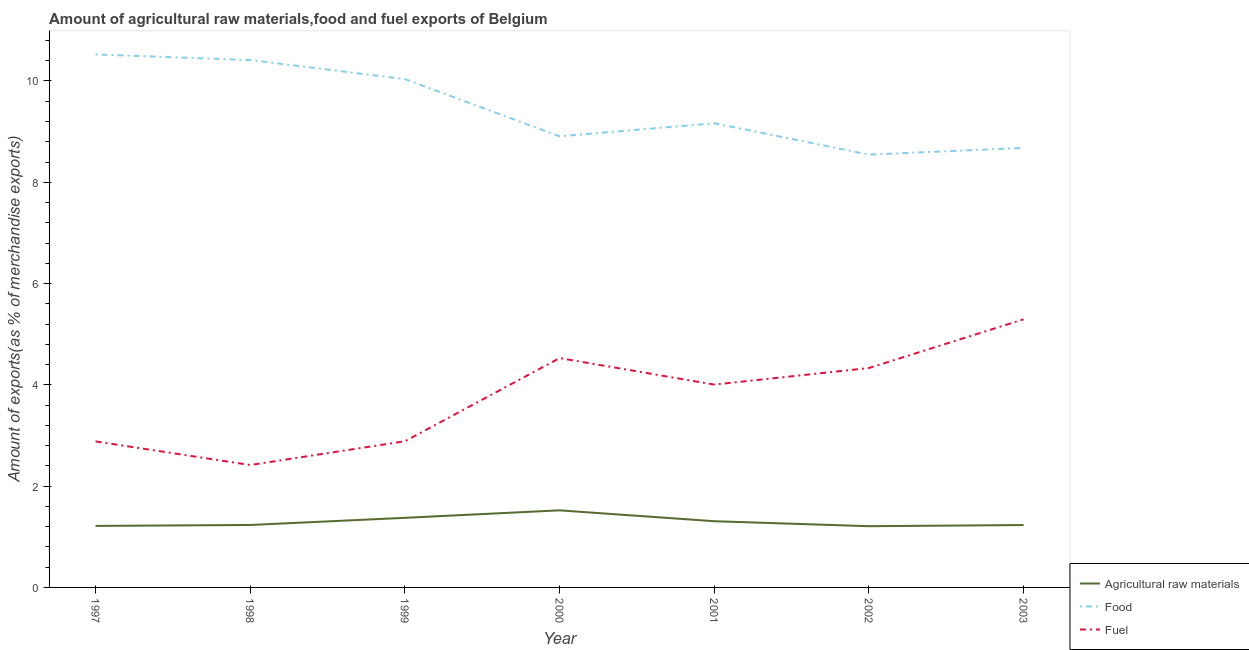How many different coloured lines are there?
Provide a succinct answer. 3. What is the percentage of food exports in 1997?
Your answer should be compact. 10.52. Across all years, what is the maximum percentage of fuel exports?
Your answer should be very brief. 5.29. Across all years, what is the minimum percentage of raw materials exports?
Offer a very short reply. 1.21. In which year was the percentage of fuel exports maximum?
Provide a succinct answer. 2003. What is the total percentage of food exports in the graph?
Make the answer very short. 66.27. What is the difference between the percentage of fuel exports in 1998 and that in 2000?
Your answer should be very brief. -2.11. What is the difference between the percentage of raw materials exports in 2000 and the percentage of food exports in 1998?
Offer a very short reply. -8.89. What is the average percentage of food exports per year?
Provide a short and direct response. 9.47. In the year 2002, what is the difference between the percentage of food exports and percentage of fuel exports?
Offer a terse response. 4.21. What is the ratio of the percentage of raw materials exports in 1997 to that in 2000?
Provide a succinct answer. 0.8. Is the difference between the percentage of raw materials exports in 1998 and 2001 greater than the difference between the percentage of fuel exports in 1998 and 2001?
Make the answer very short. Yes. What is the difference between the highest and the second highest percentage of food exports?
Offer a very short reply. 0.11. What is the difference between the highest and the lowest percentage of food exports?
Your answer should be compact. 1.98. In how many years, is the percentage of fuel exports greater than the average percentage of fuel exports taken over all years?
Your answer should be very brief. 4. Is it the case that in every year, the sum of the percentage of raw materials exports and percentage of food exports is greater than the percentage of fuel exports?
Make the answer very short. Yes. Is the percentage of food exports strictly less than the percentage of raw materials exports over the years?
Offer a terse response. No. How many lines are there?
Offer a very short reply. 3. What is the difference between two consecutive major ticks on the Y-axis?
Make the answer very short. 2. Does the graph contain any zero values?
Your answer should be very brief. No. Does the graph contain grids?
Provide a short and direct response. No. What is the title of the graph?
Offer a terse response. Amount of agricultural raw materials,food and fuel exports of Belgium. What is the label or title of the Y-axis?
Provide a short and direct response. Amount of exports(as % of merchandise exports). What is the Amount of exports(as % of merchandise exports) of Agricultural raw materials in 1997?
Offer a terse response. 1.21. What is the Amount of exports(as % of merchandise exports) in Food in 1997?
Make the answer very short. 10.52. What is the Amount of exports(as % of merchandise exports) in Fuel in 1997?
Offer a terse response. 2.88. What is the Amount of exports(as % of merchandise exports) in Agricultural raw materials in 1998?
Give a very brief answer. 1.23. What is the Amount of exports(as % of merchandise exports) of Food in 1998?
Offer a very short reply. 10.41. What is the Amount of exports(as % of merchandise exports) in Fuel in 1998?
Provide a short and direct response. 2.42. What is the Amount of exports(as % of merchandise exports) in Agricultural raw materials in 1999?
Give a very brief answer. 1.37. What is the Amount of exports(as % of merchandise exports) in Food in 1999?
Your answer should be very brief. 10.04. What is the Amount of exports(as % of merchandise exports) of Fuel in 1999?
Provide a short and direct response. 2.89. What is the Amount of exports(as % of merchandise exports) in Agricultural raw materials in 2000?
Your answer should be compact. 1.52. What is the Amount of exports(as % of merchandise exports) of Food in 2000?
Your response must be concise. 8.91. What is the Amount of exports(as % of merchandise exports) of Fuel in 2000?
Provide a short and direct response. 4.53. What is the Amount of exports(as % of merchandise exports) in Agricultural raw materials in 2001?
Ensure brevity in your answer.  1.31. What is the Amount of exports(as % of merchandise exports) in Food in 2001?
Offer a very short reply. 9.17. What is the Amount of exports(as % of merchandise exports) in Fuel in 2001?
Your answer should be compact. 4.01. What is the Amount of exports(as % of merchandise exports) of Agricultural raw materials in 2002?
Make the answer very short. 1.21. What is the Amount of exports(as % of merchandise exports) in Food in 2002?
Keep it short and to the point. 8.55. What is the Amount of exports(as % of merchandise exports) of Fuel in 2002?
Your answer should be compact. 4.33. What is the Amount of exports(as % of merchandise exports) in Agricultural raw materials in 2003?
Make the answer very short. 1.23. What is the Amount of exports(as % of merchandise exports) of Food in 2003?
Make the answer very short. 8.68. What is the Amount of exports(as % of merchandise exports) in Fuel in 2003?
Offer a very short reply. 5.29. Across all years, what is the maximum Amount of exports(as % of merchandise exports) in Agricultural raw materials?
Offer a terse response. 1.52. Across all years, what is the maximum Amount of exports(as % of merchandise exports) in Food?
Your answer should be compact. 10.52. Across all years, what is the maximum Amount of exports(as % of merchandise exports) in Fuel?
Provide a succinct answer. 5.29. Across all years, what is the minimum Amount of exports(as % of merchandise exports) of Agricultural raw materials?
Offer a very short reply. 1.21. Across all years, what is the minimum Amount of exports(as % of merchandise exports) in Food?
Keep it short and to the point. 8.55. Across all years, what is the minimum Amount of exports(as % of merchandise exports) of Fuel?
Offer a terse response. 2.42. What is the total Amount of exports(as % of merchandise exports) of Agricultural raw materials in the graph?
Provide a succinct answer. 9.09. What is the total Amount of exports(as % of merchandise exports) of Food in the graph?
Your answer should be very brief. 66.27. What is the total Amount of exports(as % of merchandise exports) in Fuel in the graph?
Offer a terse response. 26.35. What is the difference between the Amount of exports(as % of merchandise exports) in Agricultural raw materials in 1997 and that in 1998?
Your answer should be very brief. -0.02. What is the difference between the Amount of exports(as % of merchandise exports) of Food in 1997 and that in 1998?
Ensure brevity in your answer.  0.11. What is the difference between the Amount of exports(as % of merchandise exports) of Fuel in 1997 and that in 1998?
Provide a succinct answer. 0.47. What is the difference between the Amount of exports(as % of merchandise exports) of Agricultural raw materials in 1997 and that in 1999?
Keep it short and to the point. -0.16. What is the difference between the Amount of exports(as % of merchandise exports) of Food in 1997 and that in 1999?
Make the answer very short. 0.49. What is the difference between the Amount of exports(as % of merchandise exports) of Fuel in 1997 and that in 1999?
Give a very brief answer. -0. What is the difference between the Amount of exports(as % of merchandise exports) of Agricultural raw materials in 1997 and that in 2000?
Your response must be concise. -0.31. What is the difference between the Amount of exports(as % of merchandise exports) in Food in 1997 and that in 2000?
Offer a terse response. 1.62. What is the difference between the Amount of exports(as % of merchandise exports) in Fuel in 1997 and that in 2000?
Provide a short and direct response. -1.64. What is the difference between the Amount of exports(as % of merchandise exports) in Agricultural raw materials in 1997 and that in 2001?
Offer a very short reply. -0.09. What is the difference between the Amount of exports(as % of merchandise exports) in Food in 1997 and that in 2001?
Your answer should be compact. 1.36. What is the difference between the Amount of exports(as % of merchandise exports) in Fuel in 1997 and that in 2001?
Provide a short and direct response. -1.12. What is the difference between the Amount of exports(as % of merchandise exports) of Agricultural raw materials in 1997 and that in 2002?
Keep it short and to the point. 0.01. What is the difference between the Amount of exports(as % of merchandise exports) in Food in 1997 and that in 2002?
Your answer should be very brief. 1.98. What is the difference between the Amount of exports(as % of merchandise exports) of Fuel in 1997 and that in 2002?
Ensure brevity in your answer.  -1.45. What is the difference between the Amount of exports(as % of merchandise exports) of Agricultural raw materials in 1997 and that in 2003?
Offer a terse response. -0.02. What is the difference between the Amount of exports(as % of merchandise exports) in Food in 1997 and that in 2003?
Provide a short and direct response. 1.85. What is the difference between the Amount of exports(as % of merchandise exports) of Fuel in 1997 and that in 2003?
Give a very brief answer. -2.41. What is the difference between the Amount of exports(as % of merchandise exports) of Agricultural raw materials in 1998 and that in 1999?
Provide a succinct answer. -0.14. What is the difference between the Amount of exports(as % of merchandise exports) of Food in 1998 and that in 1999?
Provide a short and direct response. 0.38. What is the difference between the Amount of exports(as % of merchandise exports) in Fuel in 1998 and that in 1999?
Give a very brief answer. -0.47. What is the difference between the Amount of exports(as % of merchandise exports) of Agricultural raw materials in 1998 and that in 2000?
Your answer should be very brief. -0.29. What is the difference between the Amount of exports(as % of merchandise exports) in Food in 1998 and that in 2000?
Give a very brief answer. 1.51. What is the difference between the Amount of exports(as % of merchandise exports) of Fuel in 1998 and that in 2000?
Offer a very short reply. -2.11. What is the difference between the Amount of exports(as % of merchandise exports) of Agricultural raw materials in 1998 and that in 2001?
Give a very brief answer. -0.07. What is the difference between the Amount of exports(as % of merchandise exports) in Food in 1998 and that in 2001?
Make the answer very short. 1.25. What is the difference between the Amount of exports(as % of merchandise exports) of Fuel in 1998 and that in 2001?
Ensure brevity in your answer.  -1.59. What is the difference between the Amount of exports(as % of merchandise exports) of Agricultural raw materials in 1998 and that in 2002?
Your answer should be very brief. 0.02. What is the difference between the Amount of exports(as % of merchandise exports) of Food in 1998 and that in 2002?
Offer a very short reply. 1.87. What is the difference between the Amount of exports(as % of merchandise exports) in Fuel in 1998 and that in 2002?
Keep it short and to the point. -1.91. What is the difference between the Amount of exports(as % of merchandise exports) in Agricultural raw materials in 1998 and that in 2003?
Provide a short and direct response. 0. What is the difference between the Amount of exports(as % of merchandise exports) of Food in 1998 and that in 2003?
Ensure brevity in your answer.  1.73. What is the difference between the Amount of exports(as % of merchandise exports) of Fuel in 1998 and that in 2003?
Provide a short and direct response. -2.88. What is the difference between the Amount of exports(as % of merchandise exports) in Agricultural raw materials in 1999 and that in 2000?
Ensure brevity in your answer.  -0.15. What is the difference between the Amount of exports(as % of merchandise exports) in Food in 1999 and that in 2000?
Offer a very short reply. 1.13. What is the difference between the Amount of exports(as % of merchandise exports) in Fuel in 1999 and that in 2000?
Your answer should be very brief. -1.64. What is the difference between the Amount of exports(as % of merchandise exports) in Agricultural raw materials in 1999 and that in 2001?
Your response must be concise. 0.07. What is the difference between the Amount of exports(as % of merchandise exports) in Food in 1999 and that in 2001?
Offer a terse response. 0.87. What is the difference between the Amount of exports(as % of merchandise exports) of Fuel in 1999 and that in 2001?
Offer a terse response. -1.12. What is the difference between the Amount of exports(as % of merchandise exports) in Agricultural raw materials in 1999 and that in 2002?
Ensure brevity in your answer.  0.17. What is the difference between the Amount of exports(as % of merchandise exports) of Food in 1999 and that in 2002?
Your answer should be compact. 1.49. What is the difference between the Amount of exports(as % of merchandise exports) in Fuel in 1999 and that in 2002?
Offer a very short reply. -1.45. What is the difference between the Amount of exports(as % of merchandise exports) of Agricultural raw materials in 1999 and that in 2003?
Make the answer very short. 0.14. What is the difference between the Amount of exports(as % of merchandise exports) in Food in 1999 and that in 2003?
Provide a succinct answer. 1.36. What is the difference between the Amount of exports(as % of merchandise exports) of Fuel in 1999 and that in 2003?
Your answer should be very brief. -2.41. What is the difference between the Amount of exports(as % of merchandise exports) in Agricultural raw materials in 2000 and that in 2001?
Provide a short and direct response. 0.21. What is the difference between the Amount of exports(as % of merchandise exports) of Food in 2000 and that in 2001?
Keep it short and to the point. -0.26. What is the difference between the Amount of exports(as % of merchandise exports) in Fuel in 2000 and that in 2001?
Ensure brevity in your answer.  0.52. What is the difference between the Amount of exports(as % of merchandise exports) of Agricultural raw materials in 2000 and that in 2002?
Provide a short and direct response. 0.31. What is the difference between the Amount of exports(as % of merchandise exports) of Food in 2000 and that in 2002?
Offer a very short reply. 0.36. What is the difference between the Amount of exports(as % of merchandise exports) in Fuel in 2000 and that in 2002?
Offer a very short reply. 0.2. What is the difference between the Amount of exports(as % of merchandise exports) of Agricultural raw materials in 2000 and that in 2003?
Ensure brevity in your answer.  0.29. What is the difference between the Amount of exports(as % of merchandise exports) of Food in 2000 and that in 2003?
Your answer should be compact. 0.23. What is the difference between the Amount of exports(as % of merchandise exports) in Fuel in 2000 and that in 2003?
Your response must be concise. -0.77. What is the difference between the Amount of exports(as % of merchandise exports) of Agricultural raw materials in 2001 and that in 2002?
Give a very brief answer. 0.1. What is the difference between the Amount of exports(as % of merchandise exports) of Food in 2001 and that in 2002?
Ensure brevity in your answer.  0.62. What is the difference between the Amount of exports(as % of merchandise exports) in Fuel in 2001 and that in 2002?
Make the answer very short. -0.33. What is the difference between the Amount of exports(as % of merchandise exports) in Agricultural raw materials in 2001 and that in 2003?
Provide a short and direct response. 0.08. What is the difference between the Amount of exports(as % of merchandise exports) in Food in 2001 and that in 2003?
Keep it short and to the point. 0.49. What is the difference between the Amount of exports(as % of merchandise exports) of Fuel in 2001 and that in 2003?
Provide a succinct answer. -1.29. What is the difference between the Amount of exports(as % of merchandise exports) in Agricultural raw materials in 2002 and that in 2003?
Provide a succinct answer. -0.02. What is the difference between the Amount of exports(as % of merchandise exports) of Food in 2002 and that in 2003?
Provide a short and direct response. -0.13. What is the difference between the Amount of exports(as % of merchandise exports) of Fuel in 2002 and that in 2003?
Give a very brief answer. -0.96. What is the difference between the Amount of exports(as % of merchandise exports) in Agricultural raw materials in 1997 and the Amount of exports(as % of merchandise exports) in Food in 1998?
Your answer should be very brief. -9.2. What is the difference between the Amount of exports(as % of merchandise exports) in Agricultural raw materials in 1997 and the Amount of exports(as % of merchandise exports) in Fuel in 1998?
Make the answer very short. -1.2. What is the difference between the Amount of exports(as % of merchandise exports) of Food in 1997 and the Amount of exports(as % of merchandise exports) of Fuel in 1998?
Your answer should be compact. 8.11. What is the difference between the Amount of exports(as % of merchandise exports) of Agricultural raw materials in 1997 and the Amount of exports(as % of merchandise exports) of Food in 1999?
Make the answer very short. -8.82. What is the difference between the Amount of exports(as % of merchandise exports) in Agricultural raw materials in 1997 and the Amount of exports(as % of merchandise exports) in Fuel in 1999?
Give a very brief answer. -1.67. What is the difference between the Amount of exports(as % of merchandise exports) of Food in 1997 and the Amount of exports(as % of merchandise exports) of Fuel in 1999?
Make the answer very short. 7.64. What is the difference between the Amount of exports(as % of merchandise exports) in Agricultural raw materials in 1997 and the Amount of exports(as % of merchandise exports) in Food in 2000?
Make the answer very short. -7.69. What is the difference between the Amount of exports(as % of merchandise exports) of Agricultural raw materials in 1997 and the Amount of exports(as % of merchandise exports) of Fuel in 2000?
Your response must be concise. -3.31. What is the difference between the Amount of exports(as % of merchandise exports) in Food in 1997 and the Amount of exports(as % of merchandise exports) in Fuel in 2000?
Ensure brevity in your answer.  6. What is the difference between the Amount of exports(as % of merchandise exports) in Agricultural raw materials in 1997 and the Amount of exports(as % of merchandise exports) in Food in 2001?
Provide a succinct answer. -7.95. What is the difference between the Amount of exports(as % of merchandise exports) of Agricultural raw materials in 1997 and the Amount of exports(as % of merchandise exports) of Fuel in 2001?
Ensure brevity in your answer.  -2.79. What is the difference between the Amount of exports(as % of merchandise exports) in Food in 1997 and the Amount of exports(as % of merchandise exports) in Fuel in 2001?
Provide a short and direct response. 6.52. What is the difference between the Amount of exports(as % of merchandise exports) in Agricultural raw materials in 1997 and the Amount of exports(as % of merchandise exports) in Food in 2002?
Provide a succinct answer. -7.33. What is the difference between the Amount of exports(as % of merchandise exports) in Agricultural raw materials in 1997 and the Amount of exports(as % of merchandise exports) in Fuel in 2002?
Keep it short and to the point. -3.12. What is the difference between the Amount of exports(as % of merchandise exports) in Food in 1997 and the Amount of exports(as % of merchandise exports) in Fuel in 2002?
Provide a short and direct response. 6.19. What is the difference between the Amount of exports(as % of merchandise exports) in Agricultural raw materials in 1997 and the Amount of exports(as % of merchandise exports) in Food in 2003?
Give a very brief answer. -7.46. What is the difference between the Amount of exports(as % of merchandise exports) of Agricultural raw materials in 1997 and the Amount of exports(as % of merchandise exports) of Fuel in 2003?
Your answer should be compact. -4.08. What is the difference between the Amount of exports(as % of merchandise exports) in Food in 1997 and the Amount of exports(as % of merchandise exports) in Fuel in 2003?
Your response must be concise. 5.23. What is the difference between the Amount of exports(as % of merchandise exports) in Agricultural raw materials in 1998 and the Amount of exports(as % of merchandise exports) in Food in 1999?
Keep it short and to the point. -8.8. What is the difference between the Amount of exports(as % of merchandise exports) in Agricultural raw materials in 1998 and the Amount of exports(as % of merchandise exports) in Fuel in 1999?
Your response must be concise. -1.65. What is the difference between the Amount of exports(as % of merchandise exports) of Food in 1998 and the Amount of exports(as % of merchandise exports) of Fuel in 1999?
Keep it short and to the point. 7.53. What is the difference between the Amount of exports(as % of merchandise exports) of Agricultural raw materials in 1998 and the Amount of exports(as % of merchandise exports) of Food in 2000?
Keep it short and to the point. -7.67. What is the difference between the Amount of exports(as % of merchandise exports) in Agricultural raw materials in 1998 and the Amount of exports(as % of merchandise exports) in Fuel in 2000?
Provide a short and direct response. -3.29. What is the difference between the Amount of exports(as % of merchandise exports) in Food in 1998 and the Amount of exports(as % of merchandise exports) in Fuel in 2000?
Your response must be concise. 5.89. What is the difference between the Amount of exports(as % of merchandise exports) of Agricultural raw materials in 1998 and the Amount of exports(as % of merchandise exports) of Food in 2001?
Give a very brief answer. -7.93. What is the difference between the Amount of exports(as % of merchandise exports) of Agricultural raw materials in 1998 and the Amount of exports(as % of merchandise exports) of Fuel in 2001?
Provide a short and direct response. -2.77. What is the difference between the Amount of exports(as % of merchandise exports) of Food in 1998 and the Amount of exports(as % of merchandise exports) of Fuel in 2001?
Ensure brevity in your answer.  6.41. What is the difference between the Amount of exports(as % of merchandise exports) of Agricultural raw materials in 1998 and the Amount of exports(as % of merchandise exports) of Food in 2002?
Provide a succinct answer. -7.31. What is the difference between the Amount of exports(as % of merchandise exports) in Agricultural raw materials in 1998 and the Amount of exports(as % of merchandise exports) in Fuel in 2002?
Your answer should be compact. -3.1. What is the difference between the Amount of exports(as % of merchandise exports) of Food in 1998 and the Amount of exports(as % of merchandise exports) of Fuel in 2002?
Provide a succinct answer. 6.08. What is the difference between the Amount of exports(as % of merchandise exports) of Agricultural raw materials in 1998 and the Amount of exports(as % of merchandise exports) of Food in 2003?
Offer a terse response. -7.45. What is the difference between the Amount of exports(as % of merchandise exports) in Agricultural raw materials in 1998 and the Amount of exports(as % of merchandise exports) in Fuel in 2003?
Offer a terse response. -4.06. What is the difference between the Amount of exports(as % of merchandise exports) of Food in 1998 and the Amount of exports(as % of merchandise exports) of Fuel in 2003?
Keep it short and to the point. 5.12. What is the difference between the Amount of exports(as % of merchandise exports) of Agricultural raw materials in 1999 and the Amount of exports(as % of merchandise exports) of Food in 2000?
Provide a short and direct response. -7.53. What is the difference between the Amount of exports(as % of merchandise exports) in Agricultural raw materials in 1999 and the Amount of exports(as % of merchandise exports) in Fuel in 2000?
Give a very brief answer. -3.15. What is the difference between the Amount of exports(as % of merchandise exports) in Food in 1999 and the Amount of exports(as % of merchandise exports) in Fuel in 2000?
Your answer should be compact. 5.51. What is the difference between the Amount of exports(as % of merchandise exports) of Agricultural raw materials in 1999 and the Amount of exports(as % of merchandise exports) of Food in 2001?
Your answer should be very brief. -7.79. What is the difference between the Amount of exports(as % of merchandise exports) of Agricultural raw materials in 1999 and the Amount of exports(as % of merchandise exports) of Fuel in 2001?
Provide a succinct answer. -2.63. What is the difference between the Amount of exports(as % of merchandise exports) of Food in 1999 and the Amount of exports(as % of merchandise exports) of Fuel in 2001?
Give a very brief answer. 6.03. What is the difference between the Amount of exports(as % of merchandise exports) in Agricultural raw materials in 1999 and the Amount of exports(as % of merchandise exports) in Food in 2002?
Provide a short and direct response. -7.17. What is the difference between the Amount of exports(as % of merchandise exports) in Agricultural raw materials in 1999 and the Amount of exports(as % of merchandise exports) in Fuel in 2002?
Your answer should be very brief. -2.96. What is the difference between the Amount of exports(as % of merchandise exports) in Food in 1999 and the Amount of exports(as % of merchandise exports) in Fuel in 2002?
Your response must be concise. 5.71. What is the difference between the Amount of exports(as % of merchandise exports) in Agricultural raw materials in 1999 and the Amount of exports(as % of merchandise exports) in Food in 2003?
Provide a succinct answer. -7.3. What is the difference between the Amount of exports(as % of merchandise exports) in Agricultural raw materials in 1999 and the Amount of exports(as % of merchandise exports) in Fuel in 2003?
Your response must be concise. -3.92. What is the difference between the Amount of exports(as % of merchandise exports) in Food in 1999 and the Amount of exports(as % of merchandise exports) in Fuel in 2003?
Keep it short and to the point. 4.74. What is the difference between the Amount of exports(as % of merchandise exports) of Agricultural raw materials in 2000 and the Amount of exports(as % of merchandise exports) of Food in 2001?
Make the answer very short. -7.64. What is the difference between the Amount of exports(as % of merchandise exports) in Agricultural raw materials in 2000 and the Amount of exports(as % of merchandise exports) in Fuel in 2001?
Keep it short and to the point. -2.48. What is the difference between the Amount of exports(as % of merchandise exports) in Food in 2000 and the Amount of exports(as % of merchandise exports) in Fuel in 2001?
Keep it short and to the point. 4.9. What is the difference between the Amount of exports(as % of merchandise exports) in Agricultural raw materials in 2000 and the Amount of exports(as % of merchandise exports) in Food in 2002?
Make the answer very short. -7.02. What is the difference between the Amount of exports(as % of merchandise exports) of Agricultural raw materials in 2000 and the Amount of exports(as % of merchandise exports) of Fuel in 2002?
Provide a succinct answer. -2.81. What is the difference between the Amount of exports(as % of merchandise exports) in Food in 2000 and the Amount of exports(as % of merchandise exports) in Fuel in 2002?
Your answer should be very brief. 4.58. What is the difference between the Amount of exports(as % of merchandise exports) of Agricultural raw materials in 2000 and the Amount of exports(as % of merchandise exports) of Food in 2003?
Offer a very short reply. -7.16. What is the difference between the Amount of exports(as % of merchandise exports) of Agricultural raw materials in 2000 and the Amount of exports(as % of merchandise exports) of Fuel in 2003?
Give a very brief answer. -3.77. What is the difference between the Amount of exports(as % of merchandise exports) of Food in 2000 and the Amount of exports(as % of merchandise exports) of Fuel in 2003?
Offer a terse response. 3.61. What is the difference between the Amount of exports(as % of merchandise exports) in Agricultural raw materials in 2001 and the Amount of exports(as % of merchandise exports) in Food in 2002?
Make the answer very short. -7.24. What is the difference between the Amount of exports(as % of merchandise exports) in Agricultural raw materials in 2001 and the Amount of exports(as % of merchandise exports) in Fuel in 2002?
Provide a short and direct response. -3.02. What is the difference between the Amount of exports(as % of merchandise exports) in Food in 2001 and the Amount of exports(as % of merchandise exports) in Fuel in 2002?
Give a very brief answer. 4.83. What is the difference between the Amount of exports(as % of merchandise exports) in Agricultural raw materials in 2001 and the Amount of exports(as % of merchandise exports) in Food in 2003?
Give a very brief answer. -7.37. What is the difference between the Amount of exports(as % of merchandise exports) in Agricultural raw materials in 2001 and the Amount of exports(as % of merchandise exports) in Fuel in 2003?
Keep it short and to the point. -3.99. What is the difference between the Amount of exports(as % of merchandise exports) of Food in 2001 and the Amount of exports(as % of merchandise exports) of Fuel in 2003?
Give a very brief answer. 3.87. What is the difference between the Amount of exports(as % of merchandise exports) of Agricultural raw materials in 2002 and the Amount of exports(as % of merchandise exports) of Food in 2003?
Ensure brevity in your answer.  -7.47. What is the difference between the Amount of exports(as % of merchandise exports) in Agricultural raw materials in 2002 and the Amount of exports(as % of merchandise exports) in Fuel in 2003?
Provide a succinct answer. -4.09. What is the difference between the Amount of exports(as % of merchandise exports) of Food in 2002 and the Amount of exports(as % of merchandise exports) of Fuel in 2003?
Provide a succinct answer. 3.25. What is the average Amount of exports(as % of merchandise exports) of Agricultural raw materials per year?
Your answer should be very brief. 1.3. What is the average Amount of exports(as % of merchandise exports) of Food per year?
Your answer should be compact. 9.47. What is the average Amount of exports(as % of merchandise exports) of Fuel per year?
Your answer should be very brief. 3.76. In the year 1997, what is the difference between the Amount of exports(as % of merchandise exports) in Agricultural raw materials and Amount of exports(as % of merchandise exports) in Food?
Your response must be concise. -9.31. In the year 1997, what is the difference between the Amount of exports(as % of merchandise exports) of Agricultural raw materials and Amount of exports(as % of merchandise exports) of Fuel?
Provide a short and direct response. -1.67. In the year 1997, what is the difference between the Amount of exports(as % of merchandise exports) of Food and Amount of exports(as % of merchandise exports) of Fuel?
Keep it short and to the point. 7.64. In the year 1998, what is the difference between the Amount of exports(as % of merchandise exports) of Agricultural raw materials and Amount of exports(as % of merchandise exports) of Food?
Make the answer very short. -9.18. In the year 1998, what is the difference between the Amount of exports(as % of merchandise exports) of Agricultural raw materials and Amount of exports(as % of merchandise exports) of Fuel?
Provide a succinct answer. -1.18. In the year 1998, what is the difference between the Amount of exports(as % of merchandise exports) of Food and Amount of exports(as % of merchandise exports) of Fuel?
Your response must be concise. 8. In the year 1999, what is the difference between the Amount of exports(as % of merchandise exports) of Agricultural raw materials and Amount of exports(as % of merchandise exports) of Food?
Provide a short and direct response. -8.66. In the year 1999, what is the difference between the Amount of exports(as % of merchandise exports) of Agricultural raw materials and Amount of exports(as % of merchandise exports) of Fuel?
Provide a succinct answer. -1.51. In the year 1999, what is the difference between the Amount of exports(as % of merchandise exports) of Food and Amount of exports(as % of merchandise exports) of Fuel?
Offer a very short reply. 7.15. In the year 2000, what is the difference between the Amount of exports(as % of merchandise exports) of Agricultural raw materials and Amount of exports(as % of merchandise exports) of Food?
Your response must be concise. -7.38. In the year 2000, what is the difference between the Amount of exports(as % of merchandise exports) of Agricultural raw materials and Amount of exports(as % of merchandise exports) of Fuel?
Keep it short and to the point. -3.01. In the year 2000, what is the difference between the Amount of exports(as % of merchandise exports) of Food and Amount of exports(as % of merchandise exports) of Fuel?
Make the answer very short. 4.38. In the year 2001, what is the difference between the Amount of exports(as % of merchandise exports) in Agricultural raw materials and Amount of exports(as % of merchandise exports) in Food?
Make the answer very short. -7.86. In the year 2001, what is the difference between the Amount of exports(as % of merchandise exports) of Agricultural raw materials and Amount of exports(as % of merchandise exports) of Fuel?
Ensure brevity in your answer.  -2.7. In the year 2001, what is the difference between the Amount of exports(as % of merchandise exports) of Food and Amount of exports(as % of merchandise exports) of Fuel?
Provide a succinct answer. 5.16. In the year 2002, what is the difference between the Amount of exports(as % of merchandise exports) in Agricultural raw materials and Amount of exports(as % of merchandise exports) in Food?
Provide a short and direct response. -7.34. In the year 2002, what is the difference between the Amount of exports(as % of merchandise exports) of Agricultural raw materials and Amount of exports(as % of merchandise exports) of Fuel?
Your answer should be compact. -3.12. In the year 2002, what is the difference between the Amount of exports(as % of merchandise exports) of Food and Amount of exports(as % of merchandise exports) of Fuel?
Keep it short and to the point. 4.21. In the year 2003, what is the difference between the Amount of exports(as % of merchandise exports) in Agricultural raw materials and Amount of exports(as % of merchandise exports) in Food?
Offer a very short reply. -7.45. In the year 2003, what is the difference between the Amount of exports(as % of merchandise exports) of Agricultural raw materials and Amount of exports(as % of merchandise exports) of Fuel?
Offer a very short reply. -4.06. In the year 2003, what is the difference between the Amount of exports(as % of merchandise exports) in Food and Amount of exports(as % of merchandise exports) in Fuel?
Provide a short and direct response. 3.38. What is the ratio of the Amount of exports(as % of merchandise exports) in Agricultural raw materials in 1997 to that in 1998?
Your answer should be compact. 0.98. What is the ratio of the Amount of exports(as % of merchandise exports) in Food in 1997 to that in 1998?
Offer a very short reply. 1.01. What is the ratio of the Amount of exports(as % of merchandise exports) of Fuel in 1997 to that in 1998?
Give a very brief answer. 1.19. What is the ratio of the Amount of exports(as % of merchandise exports) of Agricultural raw materials in 1997 to that in 1999?
Provide a short and direct response. 0.88. What is the ratio of the Amount of exports(as % of merchandise exports) in Food in 1997 to that in 1999?
Your answer should be very brief. 1.05. What is the ratio of the Amount of exports(as % of merchandise exports) of Agricultural raw materials in 1997 to that in 2000?
Provide a short and direct response. 0.8. What is the ratio of the Amount of exports(as % of merchandise exports) of Food in 1997 to that in 2000?
Provide a succinct answer. 1.18. What is the ratio of the Amount of exports(as % of merchandise exports) of Fuel in 1997 to that in 2000?
Offer a very short reply. 0.64. What is the ratio of the Amount of exports(as % of merchandise exports) in Agricultural raw materials in 1997 to that in 2001?
Your response must be concise. 0.93. What is the ratio of the Amount of exports(as % of merchandise exports) of Food in 1997 to that in 2001?
Your answer should be very brief. 1.15. What is the ratio of the Amount of exports(as % of merchandise exports) of Fuel in 1997 to that in 2001?
Offer a very short reply. 0.72. What is the ratio of the Amount of exports(as % of merchandise exports) in Food in 1997 to that in 2002?
Ensure brevity in your answer.  1.23. What is the ratio of the Amount of exports(as % of merchandise exports) of Fuel in 1997 to that in 2002?
Make the answer very short. 0.67. What is the ratio of the Amount of exports(as % of merchandise exports) of Agricultural raw materials in 1997 to that in 2003?
Keep it short and to the point. 0.99. What is the ratio of the Amount of exports(as % of merchandise exports) of Food in 1997 to that in 2003?
Offer a terse response. 1.21. What is the ratio of the Amount of exports(as % of merchandise exports) of Fuel in 1997 to that in 2003?
Give a very brief answer. 0.54. What is the ratio of the Amount of exports(as % of merchandise exports) in Agricultural raw materials in 1998 to that in 1999?
Ensure brevity in your answer.  0.9. What is the ratio of the Amount of exports(as % of merchandise exports) of Food in 1998 to that in 1999?
Provide a succinct answer. 1.04. What is the ratio of the Amount of exports(as % of merchandise exports) in Fuel in 1998 to that in 1999?
Your response must be concise. 0.84. What is the ratio of the Amount of exports(as % of merchandise exports) of Agricultural raw materials in 1998 to that in 2000?
Give a very brief answer. 0.81. What is the ratio of the Amount of exports(as % of merchandise exports) in Food in 1998 to that in 2000?
Provide a succinct answer. 1.17. What is the ratio of the Amount of exports(as % of merchandise exports) of Fuel in 1998 to that in 2000?
Your answer should be very brief. 0.53. What is the ratio of the Amount of exports(as % of merchandise exports) in Agricultural raw materials in 1998 to that in 2001?
Offer a terse response. 0.94. What is the ratio of the Amount of exports(as % of merchandise exports) in Food in 1998 to that in 2001?
Give a very brief answer. 1.14. What is the ratio of the Amount of exports(as % of merchandise exports) of Fuel in 1998 to that in 2001?
Your response must be concise. 0.6. What is the ratio of the Amount of exports(as % of merchandise exports) of Agricultural raw materials in 1998 to that in 2002?
Your answer should be compact. 1.02. What is the ratio of the Amount of exports(as % of merchandise exports) of Food in 1998 to that in 2002?
Offer a very short reply. 1.22. What is the ratio of the Amount of exports(as % of merchandise exports) in Fuel in 1998 to that in 2002?
Keep it short and to the point. 0.56. What is the ratio of the Amount of exports(as % of merchandise exports) of Food in 1998 to that in 2003?
Provide a short and direct response. 1.2. What is the ratio of the Amount of exports(as % of merchandise exports) of Fuel in 1998 to that in 2003?
Make the answer very short. 0.46. What is the ratio of the Amount of exports(as % of merchandise exports) in Agricultural raw materials in 1999 to that in 2000?
Your answer should be compact. 0.9. What is the ratio of the Amount of exports(as % of merchandise exports) of Food in 1999 to that in 2000?
Provide a short and direct response. 1.13. What is the ratio of the Amount of exports(as % of merchandise exports) of Fuel in 1999 to that in 2000?
Offer a terse response. 0.64. What is the ratio of the Amount of exports(as % of merchandise exports) of Agricultural raw materials in 1999 to that in 2001?
Offer a terse response. 1.05. What is the ratio of the Amount of exports(as % of merchandise exports) of Food in 1999 to that in 2001?
Provide a succinct answer. 1.1. What is the ratio of the Amount of exports(as % of merchandise exports) in Fuel in 1999 to that in 2001?
Give a very brief answer. 0.72. What is the ratio of the Amount of exports(as % of merchandise exports) of Agricultural raw materials in 1999 to that in 2002?
Your answer should be compact. 1.14. What is the ratio of the Amount of exports(as % of merchandise exports) in Food in 1999 to that in 2002?
Your answer should be very brief. 1.17. What is the ratio of the Amount of exports(as % of merchandise exports) in Fuel in 1999 to that in 2002?
Ensure brevity in your answer.  0.67. What is the ratio of the Amount of exports(as % of merchandise exports) in Agricultural raw materials in 1999 to that in 2003?
Provide a short and direct response. 1.12. What is the ratio of the Amount of exports(as % of merchandise exports) of Food in 1999 to that in 2003?
Offer a very short reply. 1.16. What is the ratio of the Amount of exports(as % of merchandise exports) of Fuel in 1999 to that in 2003?
Provide a succinct answer. 0.55. What is the ratio of the Amount of exports(as % of merchandise exports) in Agricultural raw materials in 2000 to that in 2001?
Offer a very short reply. 1.16. What is the ratio of the Amount of exports(as % of merchandise exports) in Food in 2000 to that in 2001?
Make the answer very short. 0.97. What is the ratio of the Amount of exports(as % of merchandise exports) of Fuel in 2000 to that in 2001?
Your answer should be compact. 1.13. What is the ratio of the Amount of exports(as % of merchandise exports) of Agricultural raw materials in 2000 to that in 2002?
Keep it short and to the point. 1.26. What is the ratio of the Amount of exports(as % of merchandise exports) of Food in 2000 to that in 2002?
Provide a succinct answer. 1.04. What is the ratio of the Amount of exports(as % of merchandise exports) in Fuel in 2000 to that in 2002?
Your answer should be very brief. 1.05. What is the ratio of the Amount of exports(as % of merchandise exports) in Agricultural raw materials in 2000 to that in 2003?
Provide a succinct answer. 1.24. What is the ratio of the Amount of exports(as % of merchandise exports) in Food in 2000 to that in 2003?
Offer a terse response. 1.03. What is the ratio of the Amount of exports(as % of merchandise exports) in Fuel in 2000 to that in 2003?
Your answer should be compact. 0.86. What is the ratio of the Amount of exports(as % of merchandise exports) in Agricultural raw materials in 2001 to that in 2002?
Your answer should be compact. 1.08. What is the ratio of the Amount of exports(as % of merchandise exports) of Food in 2001 to that in 2002?
Provide a succinct answer. 1.07. What is the ratio of the Amount of exports(as % of merchandise exports) in Fuel in 2001 to that in 2002?
Offer a terse response. 0.92. What is the ratio of the Amount of exports(as % of merchandise exports) in Agricultural raw materials in 2001 to that in 2003?
Your answer should be very brief. 1.06. What is the ratio of the Amount of exports(as % of merchandise exports) of Food in 2001 to that in 2003?
Your response must be concise. 1.06. What is the ratio of the Amount of exports(as % of merchandise exports) in Fuel in 2001 to that in 2003?
Ensure brevity in your answer.  0.76. What is the ratio of the Amount of exports(as % of merchandise exports) in Agricultural raw materials in 2002 to that in 2003?
Provide a succinct answer. 0.98. What is the ratio of the Amount of exports(as % of merchandise exports) in Food in 2002 to that in 2003?
Give a very brief answer. 0.98. What is the ratio of the Amount of exports(as % of merchandise exports) of Fuel in 2002 to that in 2003?
Your answer should be very brief. 0.82. What is the difference between the highest and the second highest Amount of exports(as % of merchandise exports) of Agricultural raw materials?
Your answer should be compact. 0.15. What is the difference between the highest and the second highest Amount of exports(as % of merchandise exports) in Fuel?
Ensure brevity in your answer.  0.77. What is the difference between the highest and the lowest Amount of exports(as % of merchandise exports) of Agricultural raw materials?
Keep it short and to the point. 0.31. What is the difference between the highest and the lowest Amount of exports(as % of merchandise exports) in Food?
Make the answer very short. 1.98. What is the difference between the highest and the lowest Amount of exports(as % of merchandise exports) in Fuel?
Offer a terse response. 2.88. 